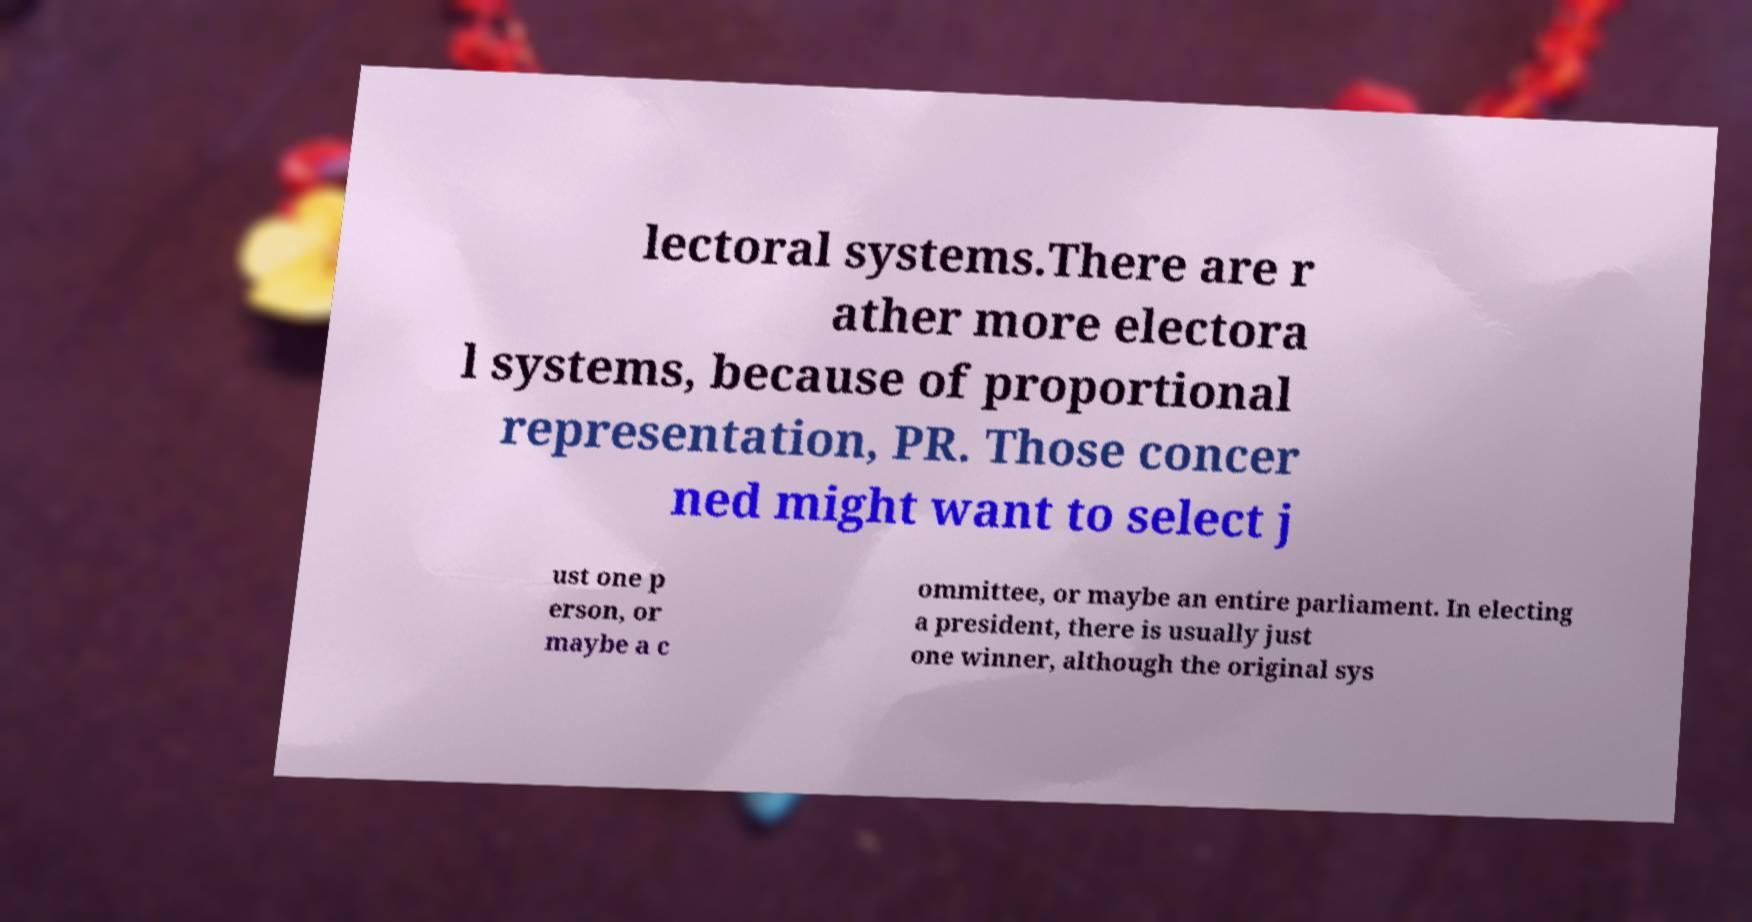Please identify and transcribe the text found in this image. lectoral systems.There are r ather more electora l systems, because of proportional representation, PR. Those concer ned might want to select j ust one p erson, or maybe a c ommittee, or maybe an entire parliament. In electing a president, there is usually just one winner, although the original sys 